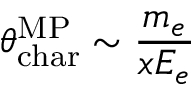<formula> <loc_0><loc_0><loc_500><loc_500>\theta _ { c h a r } ^ { M P } \sim \frac { m _ { e } } { x E _ { e } }</formula> 